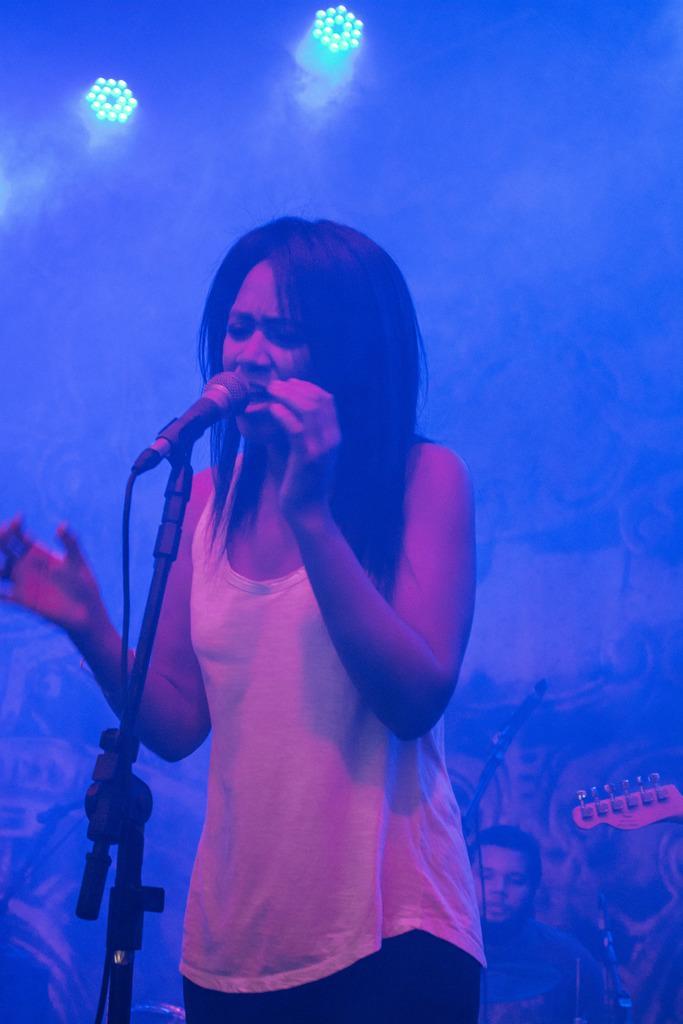Please provide a concise description of this image. A person is standing and singing. There is a microphone and its stand present in front of her. There are other people behind her. There are lights on the top. 